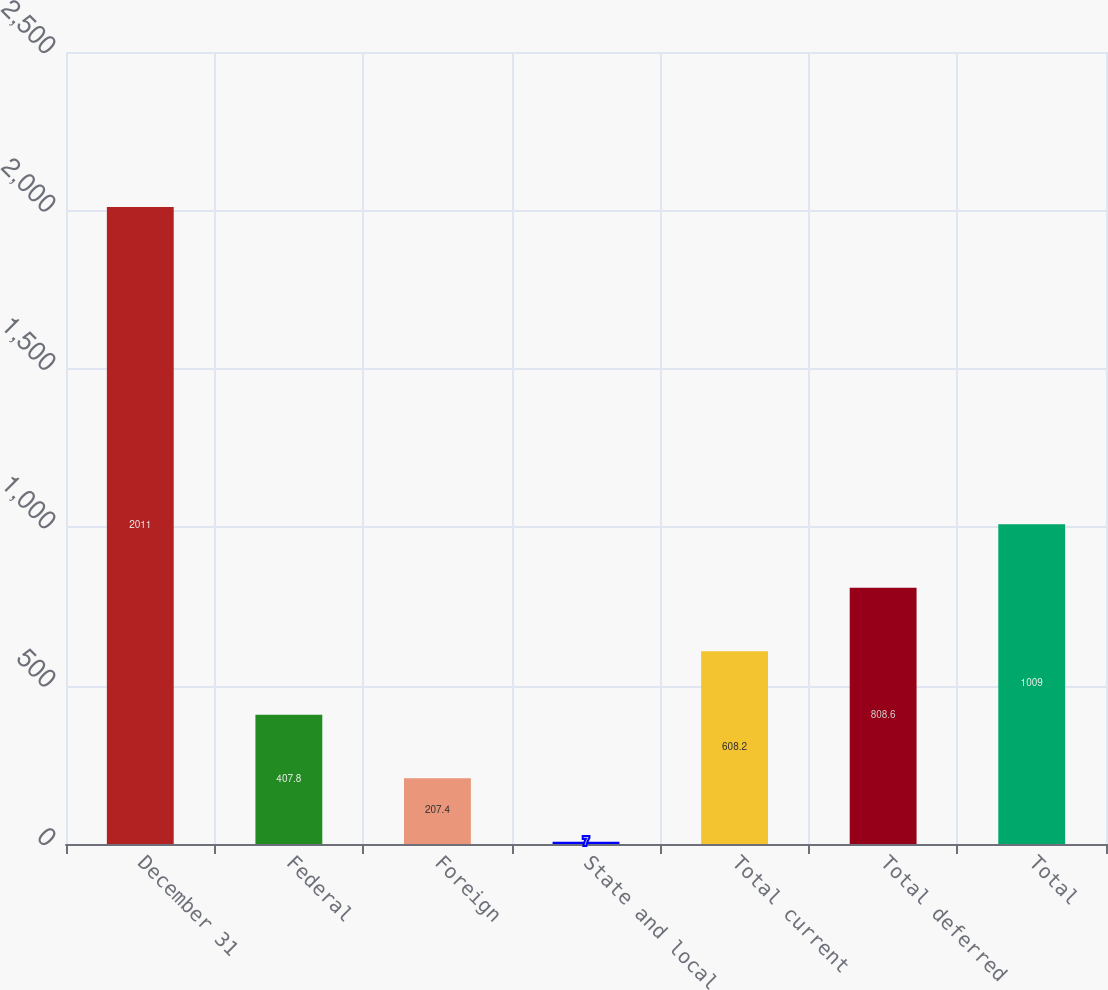<chart> <loc_0><loc_0><loc_500><loc_500><bar_chart><fcel>December 31<fcel>Federal<fcel>Foreign<fcel>State and local<fcel>Total current<fcel>Total deferred<fcel>Total<nl><fcel>2011<fcel>407.8<fcel>207.4<fcel>7<fcel>608.2<fcel>808.6<fcel>1009<nl></chart> 